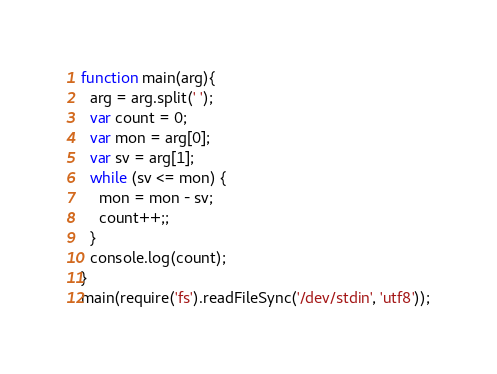Convert code to text. <code><loc_0><loc_0><loc_500><loc_500><_JavaScript_>function main(arg){
  arg = arg.split(' ');
  var count = 0;
  var mon = arg[0];
  var sv = arg[1];
  while (sv <= mon) {
  	mon = mon - sv;
    count++;;
  }
  console.log(count);
}
main(require('fs').readFileSync('/dev/stdin', 'utf8'));</code> 